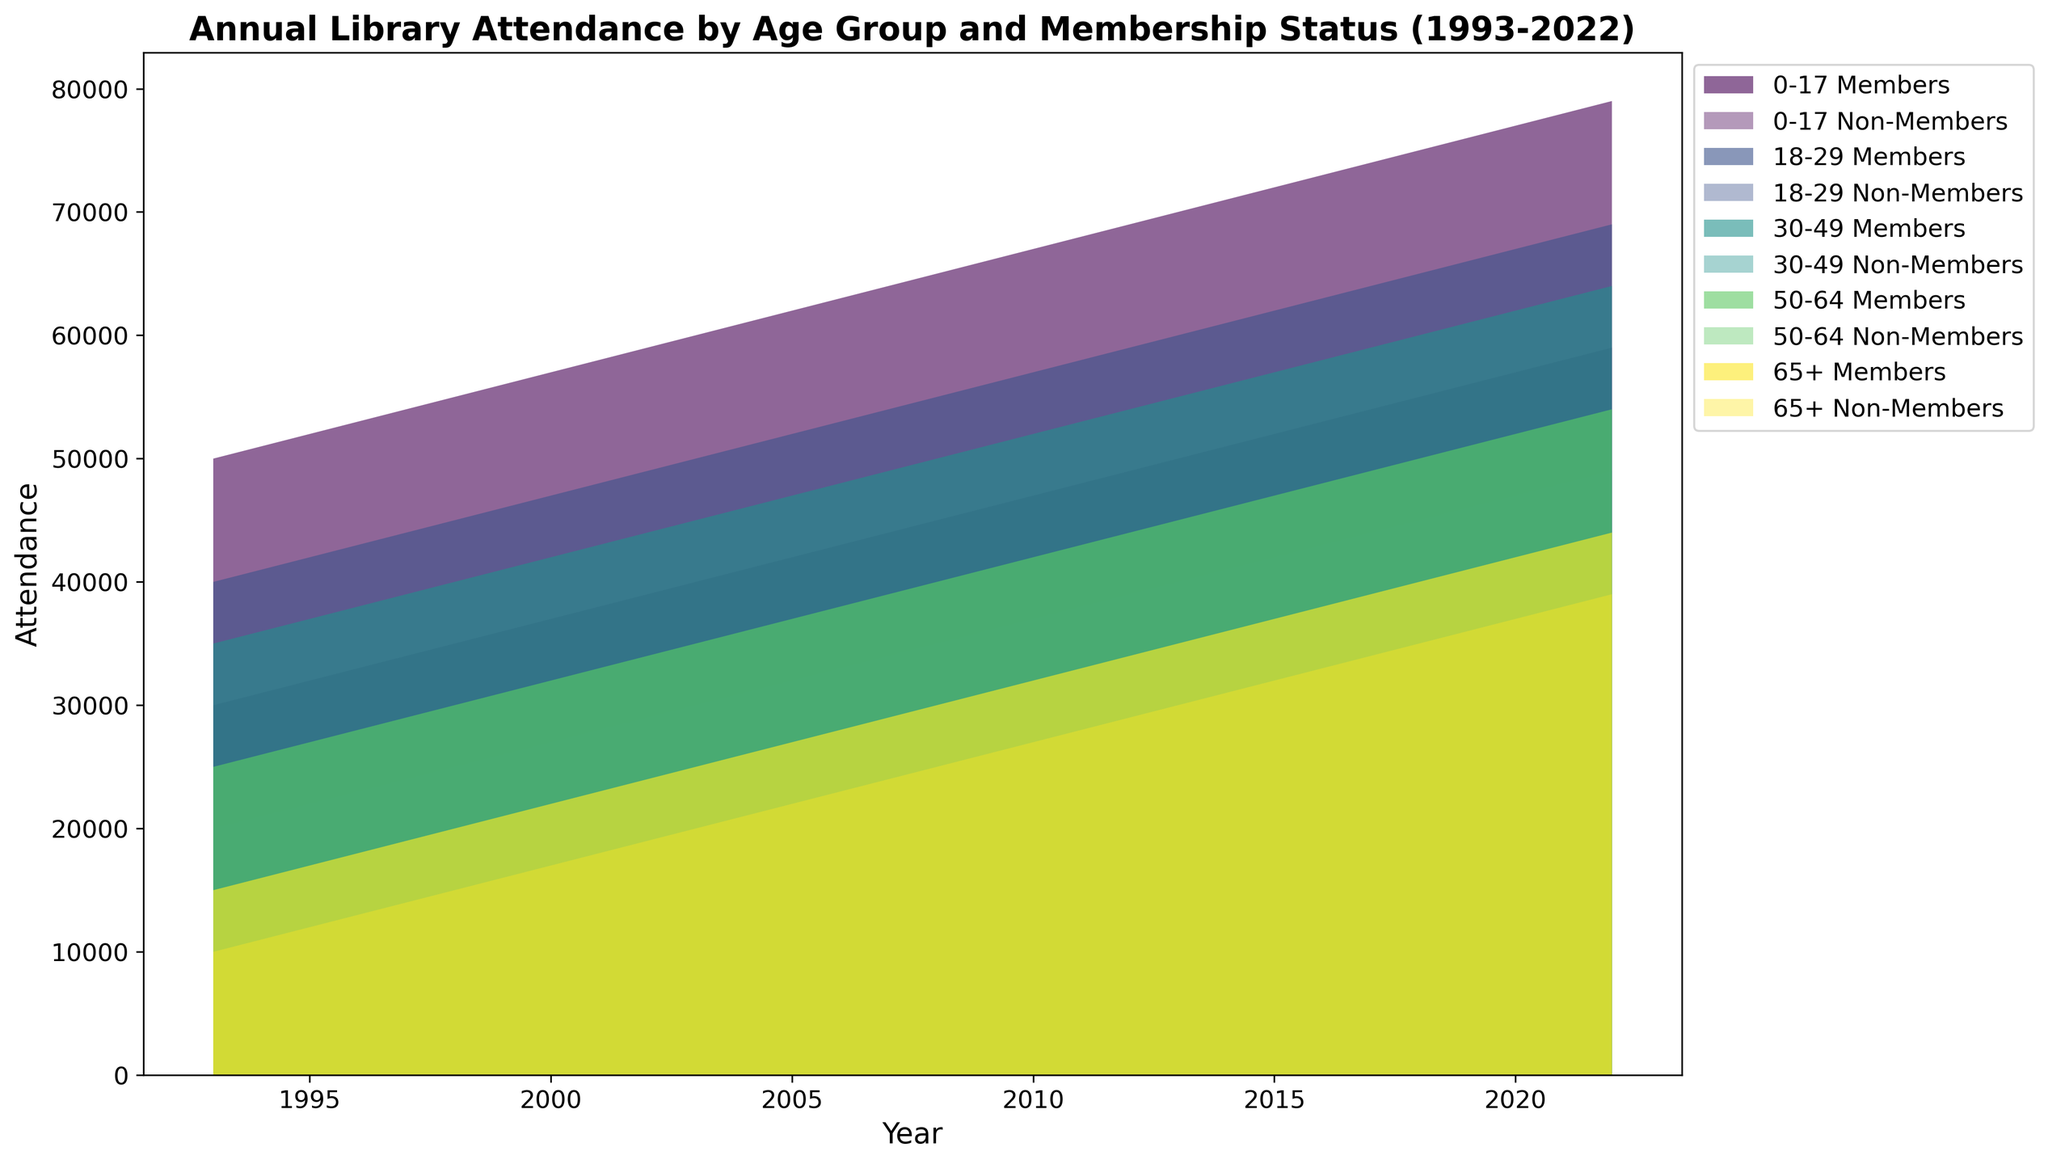What's the trend in library attendance for the 0-17 age group over the years? To identify the trend, examine the height of the areas for the 0-17 age group. The areas show an increasing trend for both members and non-members from 1993 to 2022. This indicates a steady rise in library attendance over the years for the 0-17 age group.
Answer: Increasing Which age group had the highest attendance in 2022? By comparing the heights of the stacked areas for all age groups in 2022, the 0-17 age group has the highest combined attendance as it occupies the most space on the y-axis.
Answer: 0-17 What is the difference in attendance between members and non-members for the 18-29 age group in 2010? Locate the year 2010 on the x-axis, then identify the area heights for the 18-29 age group. Sum these heights for both members and non-members. Attendance for members is about 57,000, and for non-members, it’s 37,000. So, the difference is 57,000 - 37,000 = 20,000.
Answer: 20,000 In which year did the 30-49 age group membership attendance surpass 50,000? Look at the 30-49 age group area over the x-axis years and find the first year when its height crosses the 50,000 mark. The year is around 2008.
Answer: 2008 How did attendance for non-members (65+) compare in 2000 and 2020? Compare the heights of the non-member area for the 65+ age group at the years 2000 and 2020. Attendance in 2000 is around 17,000, while in 2020 it is about 37,000, showing an increase.
Answer: Increased What is the sum of member attendances across all age groups in 2015? To find the sum, add up the attendance of members for each age group in 2015. 0-17: 72,000; 18-29: 62,000; 30-49: 57,000; 50-64: 47,000; 65+: 37,000. Sum = 72,000 + 62,000 + 57,000 + 47,000 + 37,000 = 275,000.
Answer: 275,000 Which age group shows the largest growth in non-member attendance from 1993 to 2022? Calculate the difference in non-member attendance for each age group between 1993 and 2022. 0-17: 59,000 - 30,000 = 29,000; 18-29: 49,000 - 20,000 = 29,000; 30-49: 54,000 - 25,000 = 29,000; 50-64: 44,000 - 15,000 = 29,000; 65+: 39,000 - 10,000 = 29,000. All age groups have equal growth, so they all show the same growth.
Answer: All age groups show equal growth of 29,000 What's the trend of library attendance for 50-64 age group members after 2010? Observe the 50-64 age group members data starting from 2010 onward. The heights of the member area for this group exhibit a continuous increase from 2010 (42,000) to 2022 (54,000).
Answer: Increasing In 2019, did non-members in the 30-49 age group have higher attendance than members in the 50-64 age group? Compare the heights of the non-member area of the 30-49 group and the member area of the 50-64 group for 2019. Non-members (30-49) have attendance of 51,000, while members (50-64) have 51,000. They are equal.
Answer: Equal 